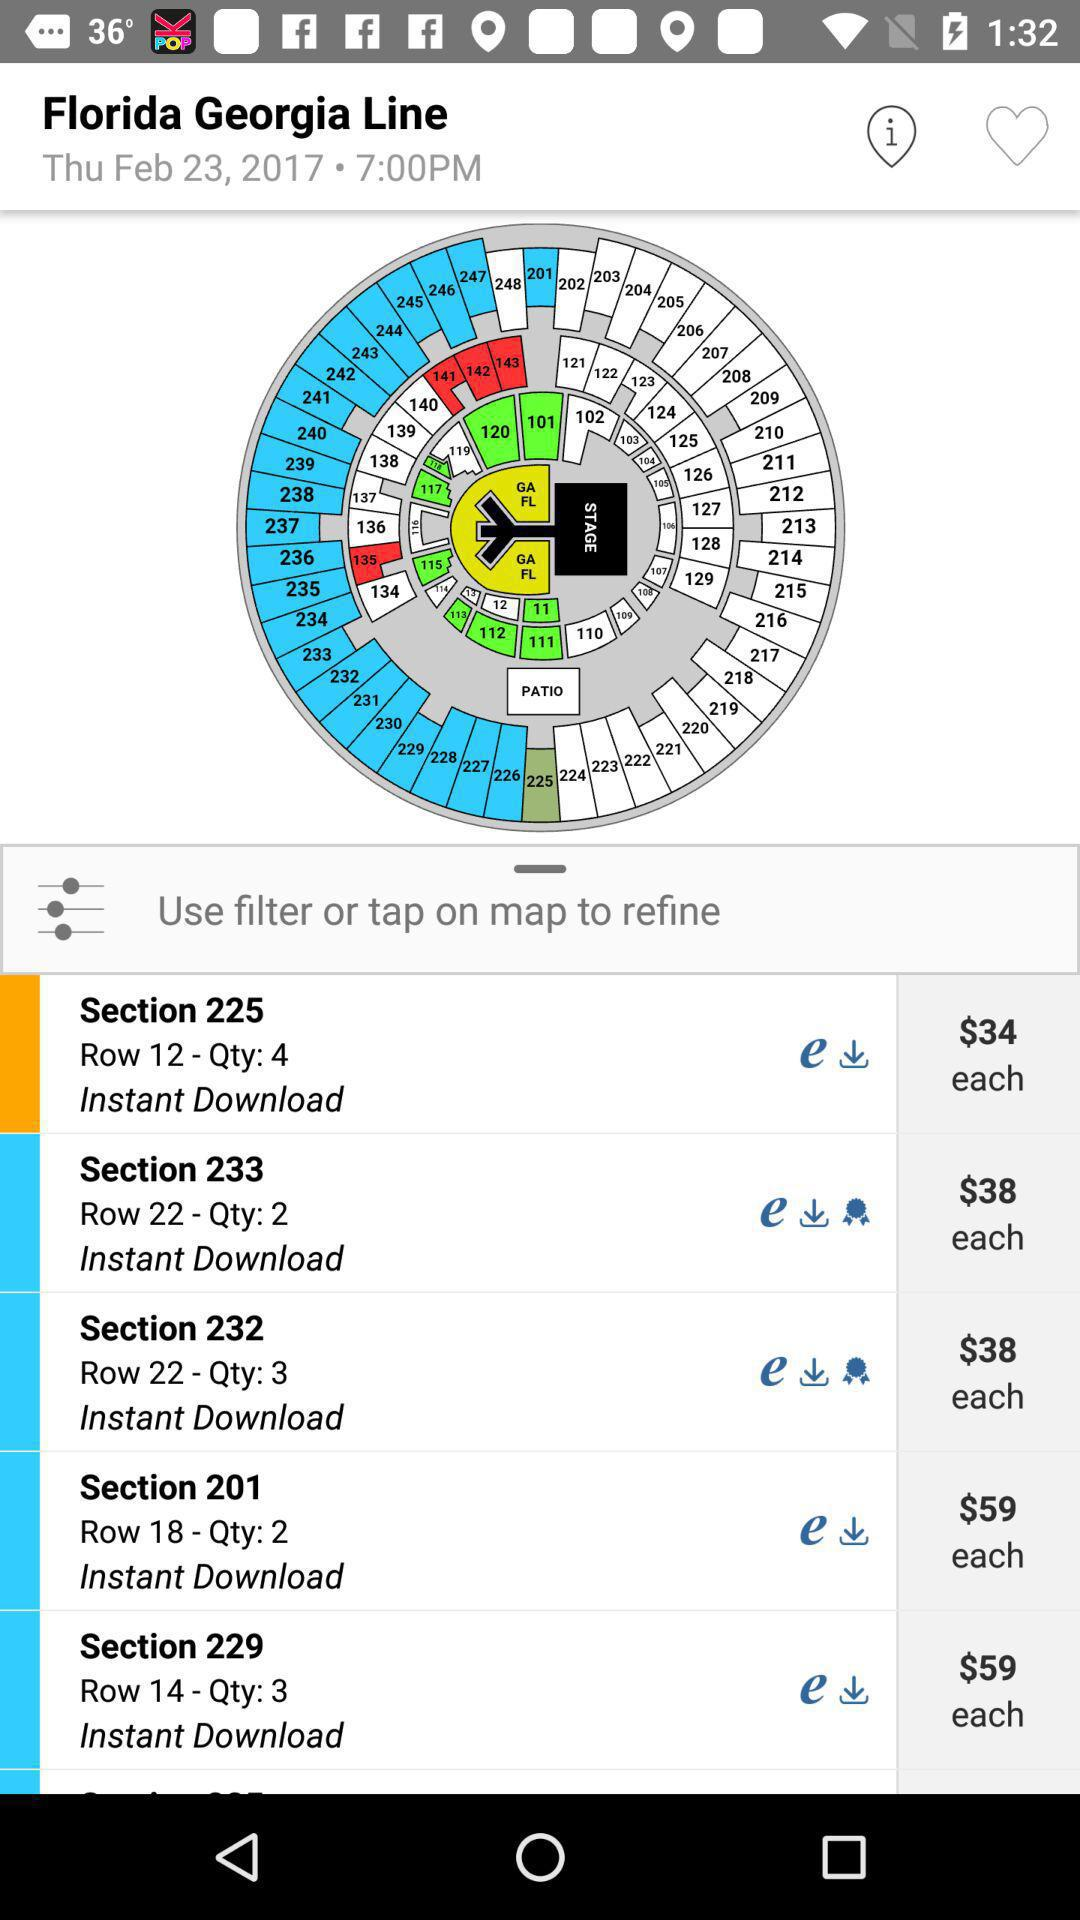What quantity does Section 201 contain? It contains 2 quantities. 